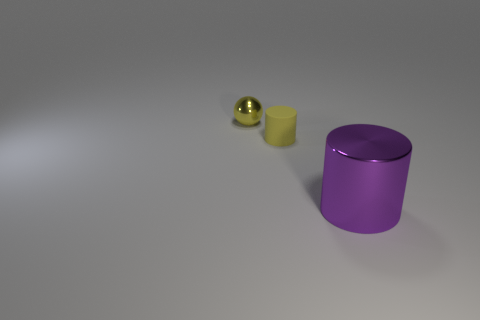Add 3 big purple metal cylinders. How many objects exist? 6 Subtract 2 cylinders. How many cylinders are left? 0 Subtract all spheres. How many objects are left? 2 Add 1 small yellow metallic balls. How many small yellow metallic balls are left? 2 Add 3 big shiny objects. How many big shiny objects exist? 4 Subtract all purple cylinders. How many cylinders are left? 1 Subtract 0 cyan spheres. How many objects are left? 3 Subtract all red balls. Subtract all purple cylinders. How many balls are left? 1 Subtract all gray cylinders. How many green spheres are left? 0 Subtract all tiny blue rubber blocks. Subtract all large metal cylinders. How many objects are left? 2 